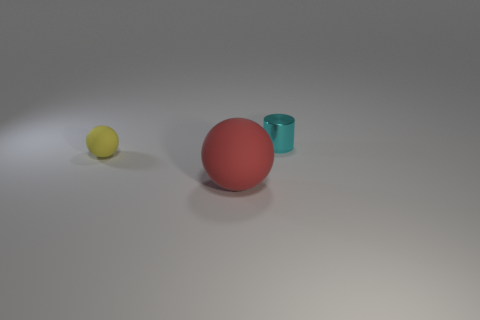Is there any indication about the relative softness or hardness of these objects? While the image doesn't allow us to physically test the objects' texture, the small deformations and the way light diffuses off the surfaces of the yellow and red spheres suggest that they are likely made of a relatively soft material like rubber. In contrast, the turquoise cylinder's more rigid edges and smooth surface hint at a harder material, which could be a type of plastic or metal. 